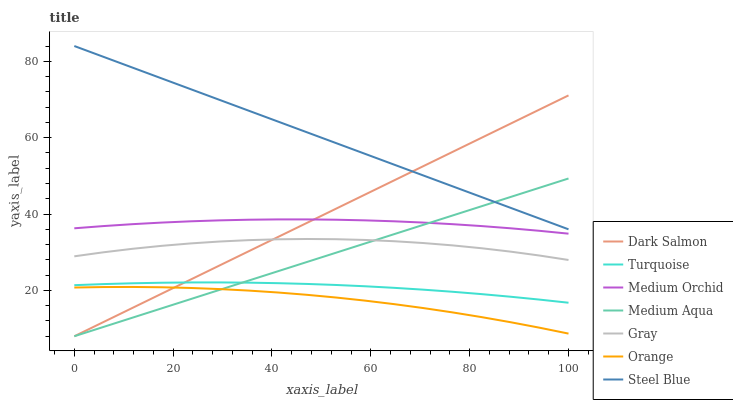Does Orange have the minimum area under the curve?
Answer yes or no. Yes. Does Turquoise have the minimum area under the curve?
Answer yes or no. No. Does Turquoise have the maximum area under the curve?
Answer yes or no. No. Is Gray the roughest?
Answer yes or no. Yes. Is Turquoise the smoothest?
Answer yes or no. No. Is Turquoise the roughest?
Answer yes or no. No. Does Turquoise have the lowest value?
Answer yes or no. No. Does Turquoise have the highest value?
Answer yes or no. No. Is Turquoise less than Gray?
Answer yes or no. Yes. Is Steel Blue greater than Medium Orchid?
Answer yes or no. Yes. Does Turquoise intersect Gray?
Answer yes or no. No. 